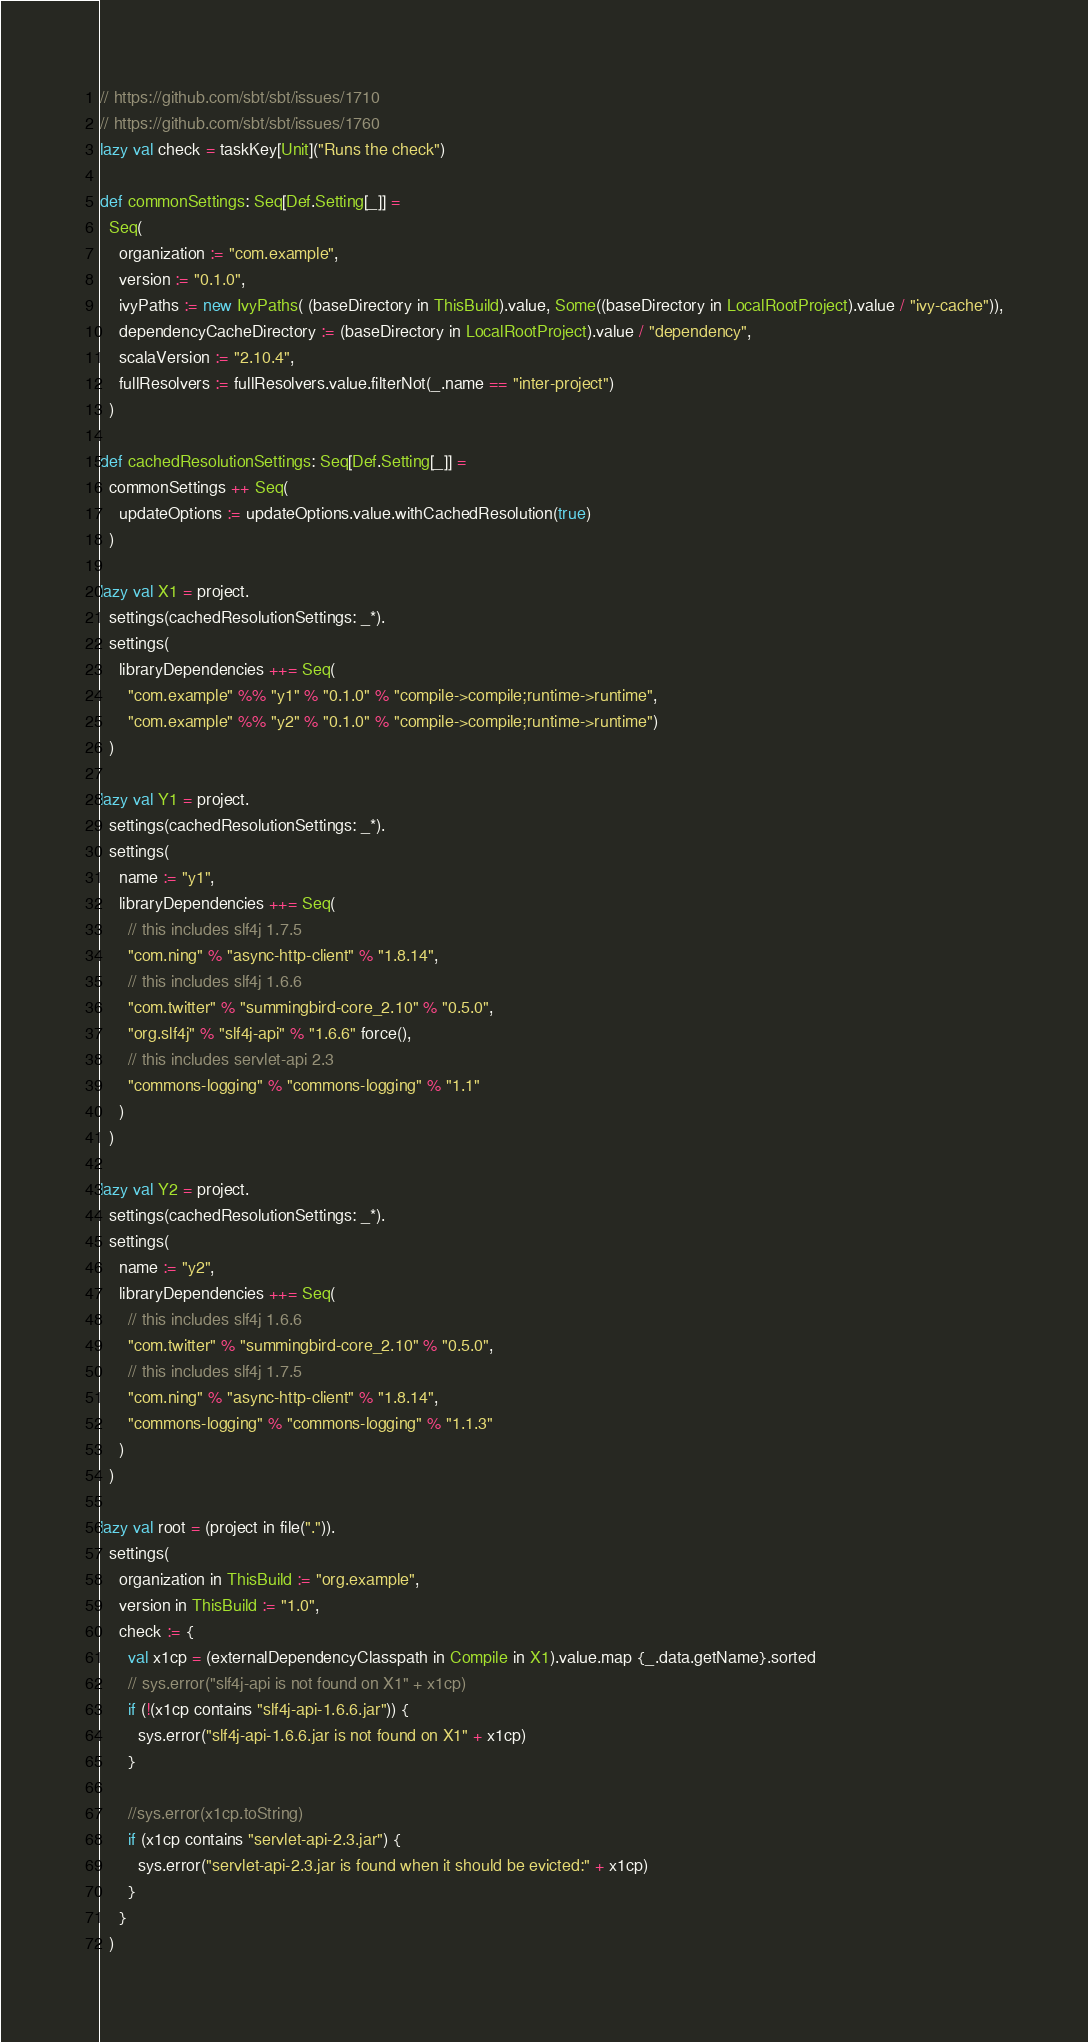<code> <loc_0><loc_0><loc_500><loc_500><_Scala_>// https://github.com/sbt/sbt/issues/1710
// https://github.com/sbt/sbt/issues/1760
lazy val check = taskKey[Unit]("Runs the check")

def commonSettings: Seq[Def.Setting[_]] =
  Seq(
    organization := "com.example",
    version := "0.1.0",
    ivyPaths := new IvyPaths( (baseDirectory in ThisBuild).value, Some((baseDirectory in LocalRootProject).value / "ivy-cache")),
    dependencyCacheDirectory := (baseDirectory in LocalRootProject).value / "dependency",
    scalaVersion := "2.10.4",
    fullResolvers := fullResolvers.value.filterNot(_.name == "inter-project")
  )

def cachedResolutionSettings: Seq[Def.Setting[_]] =
  commonSettings ++ Seq(
    updateOptions := updateOptions.value.withCachedResolution(true)
  )

lazy val X1 = project.
  settings(cachedResolutionSettings: _*).
  settings(
    libraryDependencies ++= Seq(
      "com.example" %% "y1" % "0.1.0" % "compile->compile;runtime->runtime",
      "com.example" %% "y2" % "0.1.0" % "compile->compile;runtime->runtime")
  )

lazy val Y1 = project.
  settings(cachedResolutionSettings: _*).
  settings(
    name := "y1",
    libraryDependencies ++= Seq(
      // this includes slf4j 1.7.5
      "com.ning" % "async-http-client" % "1.8.14",
      // this includes slf4j 1.6.6
      "com.twitter" % "summingbird-core_2.10" % "0.5.0",
      "org.slf4j" % "slf4j-api" % "1.6.6" force(),
      // this includes servlet-api 2.3
      "commons-logging" % "commons-logging" % "1.1"
    )
  )

lazy val Y2 = project.
  settings(cachedResolutionSettings: _*).
  settings(
    name := "y2",
    libraryDependencies ++= Seq(
      // this includes slf4j 1.6.6
      "com.twitter" % "summingbird-core_2.10" % "0.5.0",
      // this includes slf4j 1.7.5
      "com.ning" % "async-http-client" % "1.8.14",
      "commons-logging" % "commons-logging" % "1.1.3"
    )
  )

lazy val root = (project in file(".")).
  settings(
    organization in ThisBuild := "org.example",
    version in ThisBuild := "1.0",
    check := {
      val x1cp = (externalDependencyClasspath in Compile in X1).value.map {_.data.getName}.sorted
      // sys.error("slf4j-api is not found on X1" + x1cp)
      if (!(x1cp contains "slf4j-api-1.6.6.jar")) {
        sys.error("slf4j-api-1.6.6.jar is not found on X1" + x1cp)
      }

      //sys.error(x1cp.toString)
      if (x1cp contains "servlet-api-2.3.jar") {
        sys.error("servlet-api-2.3.jar is found when it should be evicted:" + x1cp)
      } 
    }
  )
</code> 